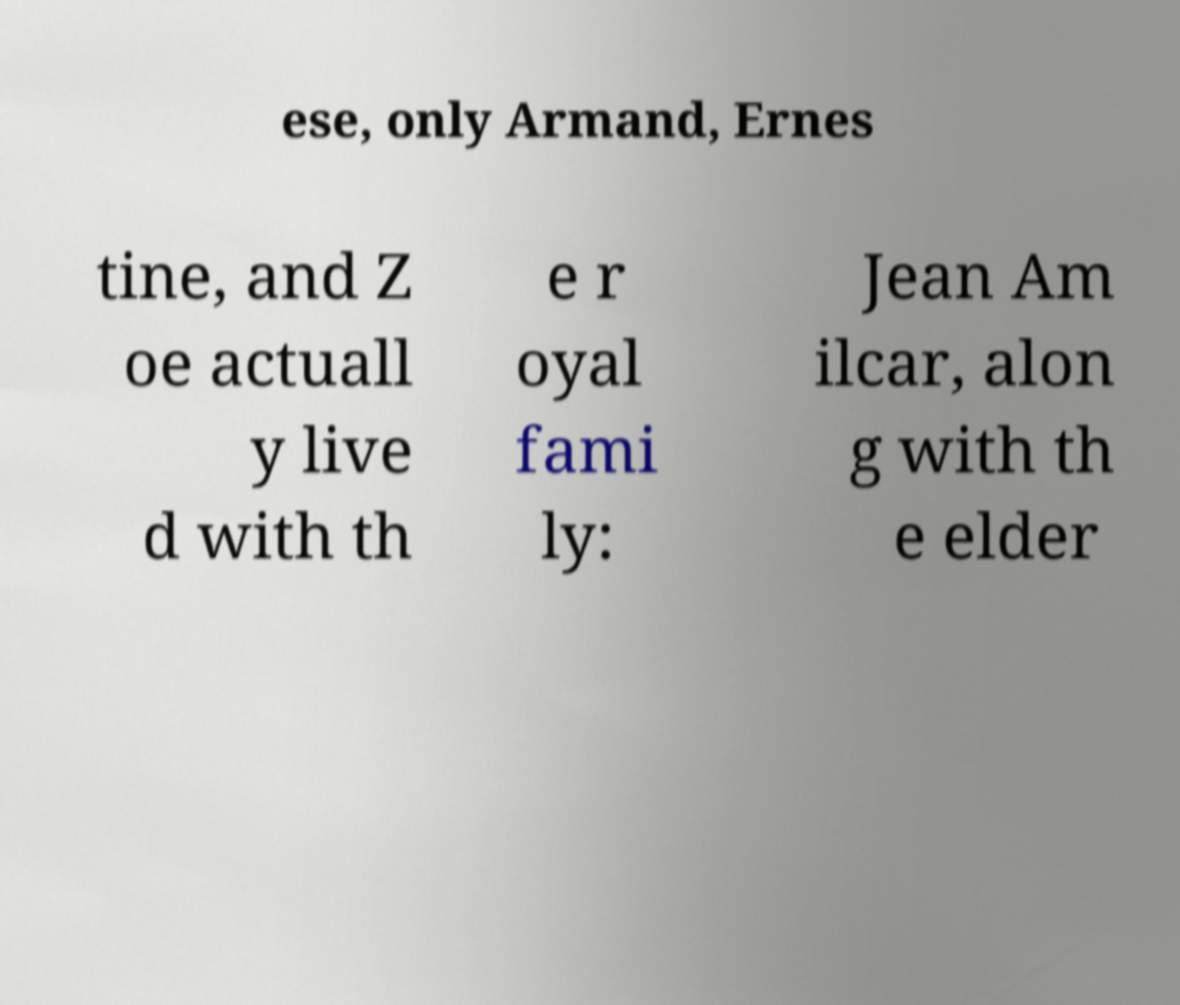Could you extract and type out the text from this image? ese, only Armand, Ernes tine, and Z oe actuall y live d with th e r oyal fami ly: Jean Am ilcar, alon g with th e elder 